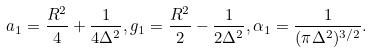<formula> <loc_0><loc_0><loc_500><loc_500>a _ { 1 } = \frac { R ^ { 2 } } { 4 } + \frac { 1 } { 4 \Delta ^ { 2 } } , g _ { 1 } = \frac { R ^ { 2 } } { 2 } - \frac { 1 } { 2 \Delta ^ { 2 } } , \alpha _ { 1 } = \frac { 1 } { ( \pi \Delta ^ { 2 } ) ^ { 3 / 2 } } .</formula> 